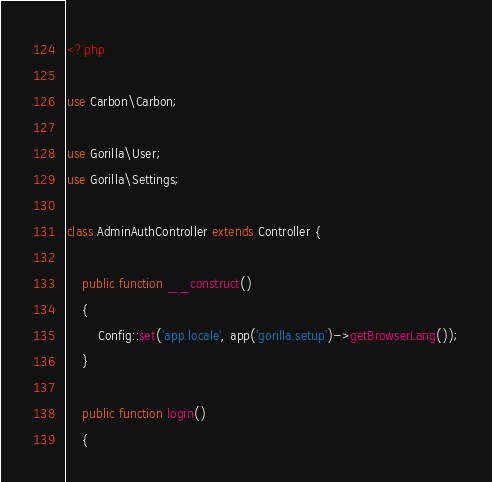Convert code to text. <code><loc_0><loc_0><loc_500><loc_500><_PHP_><?php

use Carbon\Carbon;

use Gorilla\User;
use Gorilla\Settings;

class AdminAuthController extends Controller {

	public function __construct()
	{
		Config::set('app.locale', app('gorilla.setup')->getBrowserLang());
	}

	public function login()
	{</code> 